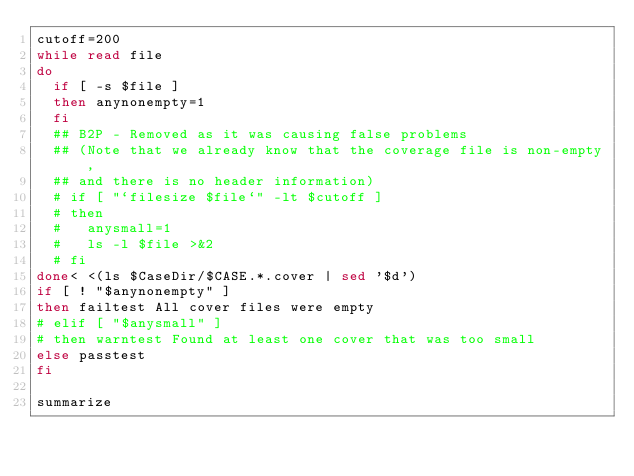Convert code to text. <code><loc_0><loc_0><loc_500><loc_500><_Bash_>cutoff=200
while read file
do
  if [ -s $file ]
  then anynonempty=1
  fi
  ## B2P - Removed as it was causing false problems
  ## (Note that we already know that the coverage file is non-empty,
  ## and there is no header information)
  # if [ "`filesize $file`" -lt $cutoff ]
  # then
  #   anysmall=1
  #   ls -l $file >&2
  # fi
done< <(ls $CaseDir/$CASE.*.cover | sed '$d')
if [ ! "$anynonempty" ]
then failtest All cover files were empty
# elif [ "$anysmall" ]
# then warntest Found at least one cover that was too small
else passtest
fi

summarize
</code> 